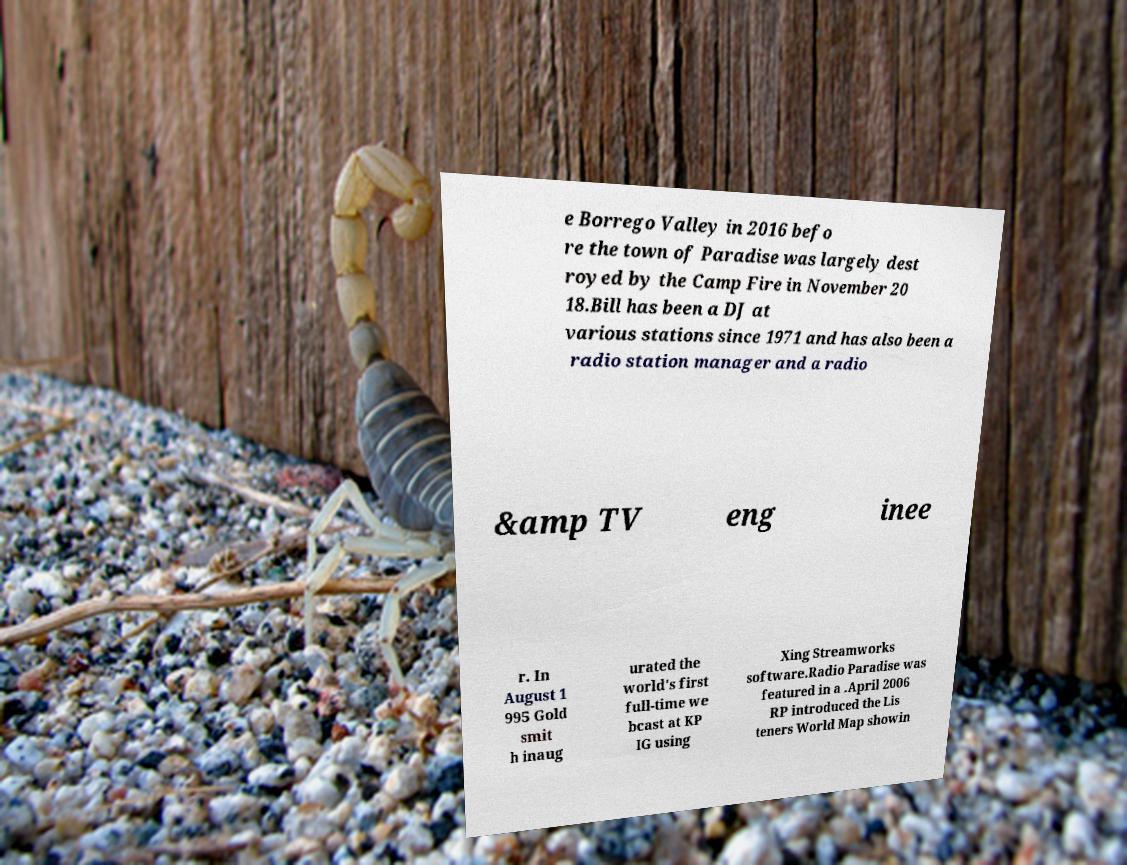Could you extract and type out the text from this image? e Borrego Valley in 2016 befo re the town of Paradise was largely dest royed by the Camp Fire in November 20 18.Bill has been a DJ at various stations since 1971 and has also been a radio station manager and a radio &amp TV eng inee r. In August 1 995 Gold smit h inaug urated the world's first full-time we bcast at KP IG using Xing Streamworks software.Radio Paradise was featured in a .April 2006 RP introduced the Lis teners World Map showin 